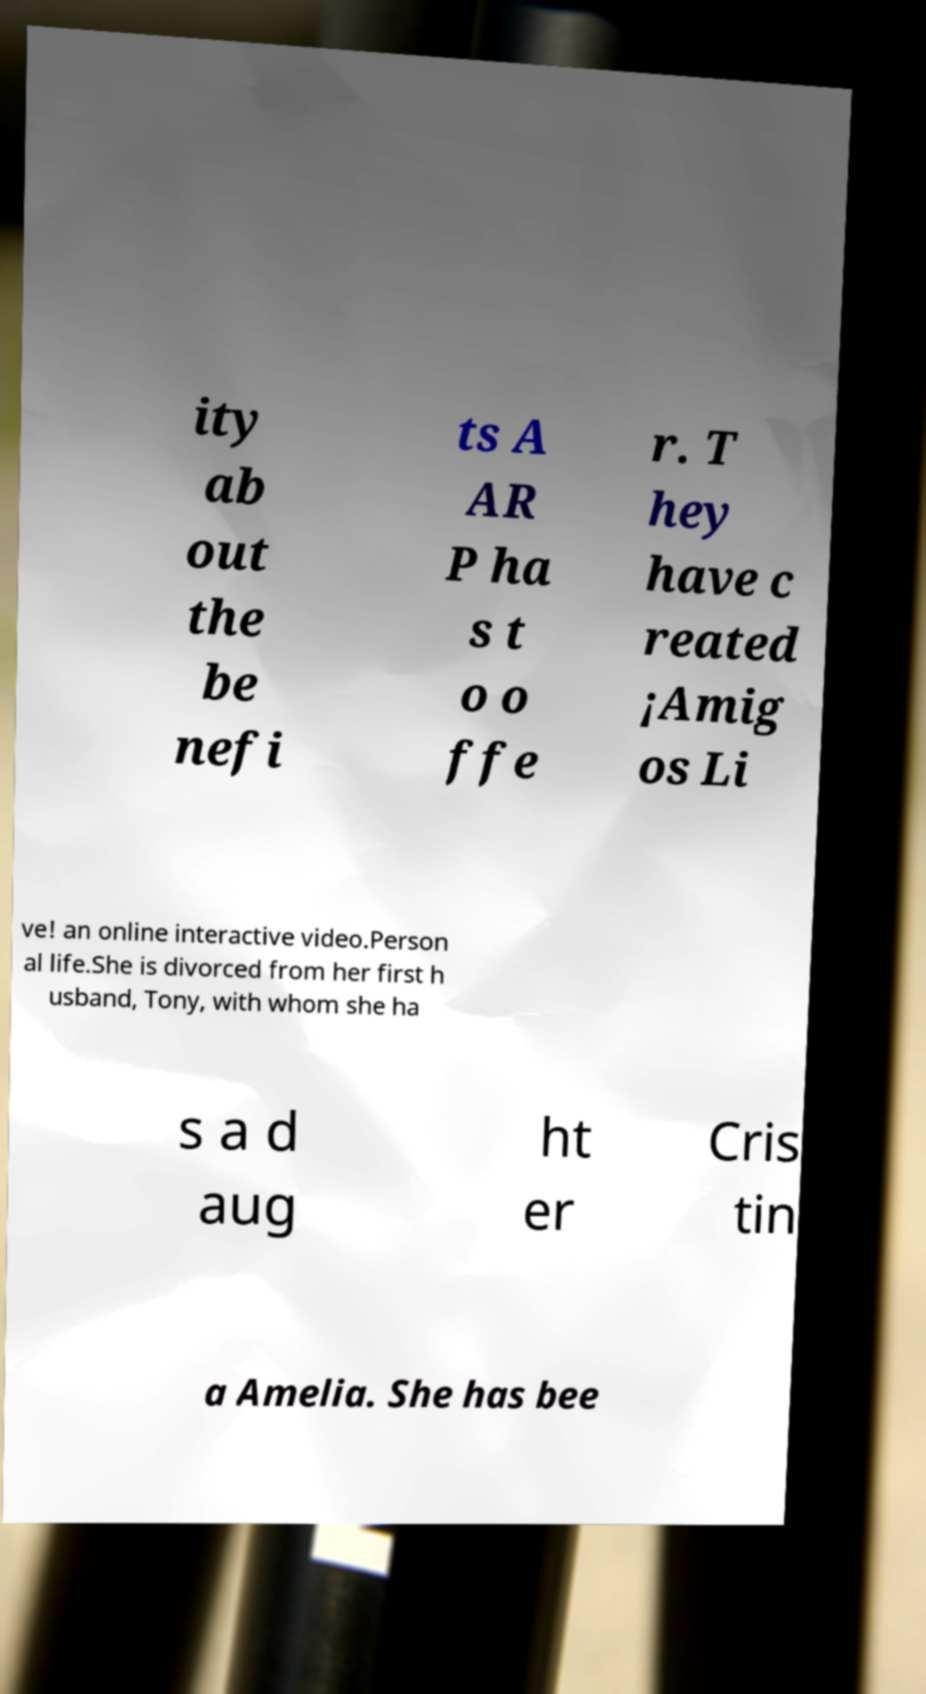I need the written content from this picture converted into text. Can you do that? ity ab out the be nefi ts A AR P ha s t o o ffe r. T hey have c reated ¡Amig os Li ve! an online interactive video.Person al life.She is divorced from her first h usband, Tony, with whom she ha s a d aug ht er Cris tin a Amelia. She has bee 